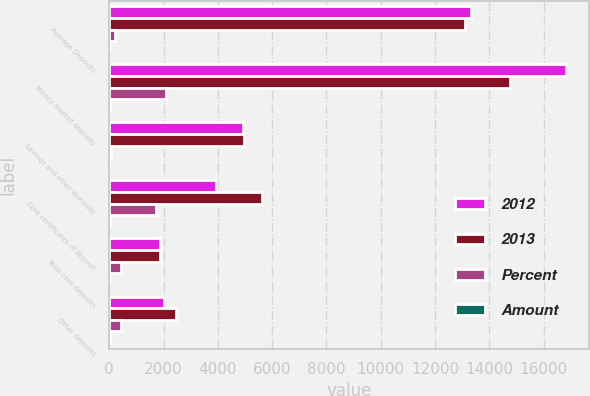<chart> <loc_0><loc_0><loc_500><loc_500><stacked_bar_chart><ecel><fcel>Average Deposits<fcel>Money market deposits<fcel>Savings and other domestic<fcel>Core certificates of deposit<fcel>Total core deposits<fcel>Other deposits<nl><fcel>2012<fcel>13337<fcel>16827<fcel>4912<fcel>3916<fcel>1874<fcel>2027<nl><fcel>2013<fcel>13121<fcel>14749<fcel>4960<fcel>5637<fcel>1874<fcel>2457<nl><fcel>Percent<fcel>216<fcel>2078<fcel>48<fcel>1721<fcel>437<fcel>430<nl><fcel>Amount<fcel>2<fcel>14<fcel>1<fcel>31<fcel>1<fcel>18<nl></chart> 